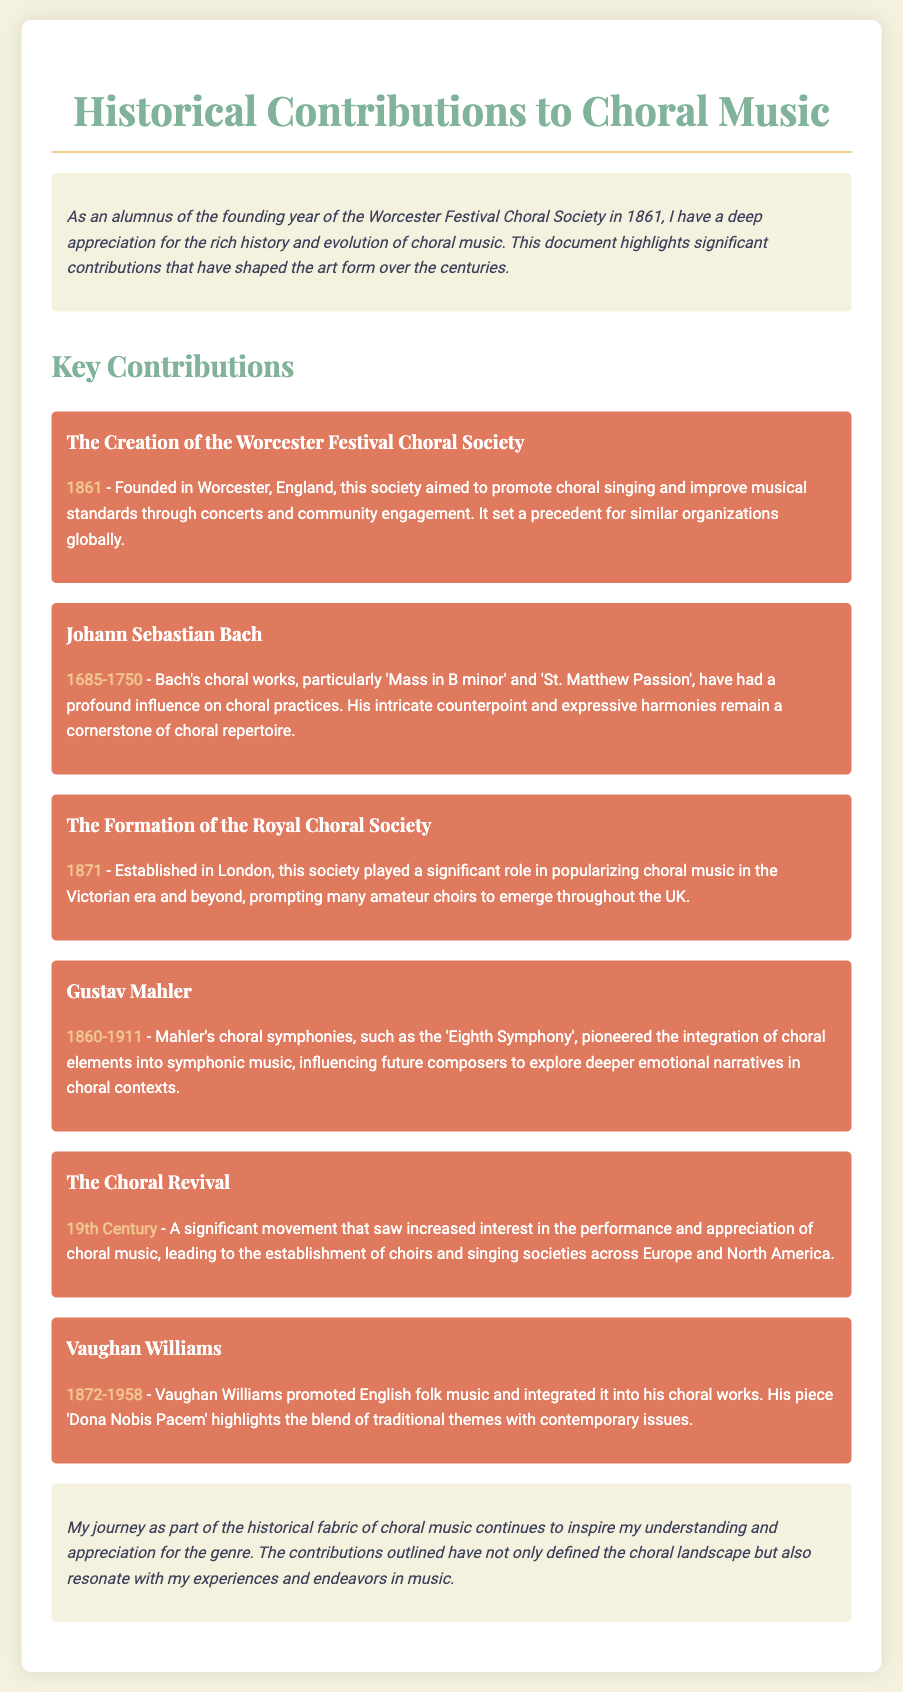What year was the Worcester Festival Choral Society founded? The document states that the Worcester Festival Choral Society was founded in 1861.
Answer: 1861 Who composed the 'Mass in B minor'? Johann Sebastian Bach is credited with composing the 'Mass in B minor' as per the document.
Answer: Johann Sebastian Bach What major event occurred in 1871 related to choral music? The document notes that the Royal Choral Society was established in 1871, which is a major event.
Answer: Established Royal Choral Society Which composer is associated with the 'Eighth Symphony'? Gustav Mahler is mentioned in connection with the 'Eighth Symphony' in the contributions outlined.
Answer: Gustav Mahler What century did the Choral Revival take place? The document states that the Choral Revival occurred in the 19th Century.
Answer: 19th Century Which English composer promoted folk music in choral works? Vaughan Williams is noted for promoting English folk music in his choral works in the document.
Answer: Vaughan Williams Explain the significance of the Worcester Festival Choral Society. The society aimed to promote choral singing and improve musical standards, setting a precedent for similar organizations globally.
Answer: Promoted choral singing and set a precedent What does the introduction highlight about the author's perspective? The introduction expresses a deep appreciation for the history and evolution of choral music from the author's viewpoint as an alumnus.
Answer: Deep appreciation for choral music history What does the conclusion reflect about the author's ongoing relationship with choral music? The conclusion states that the author's journey in choral music continues to inspire their understanding and appreciation of the genre.
Answer: Ongoing inspiration and appreciation 